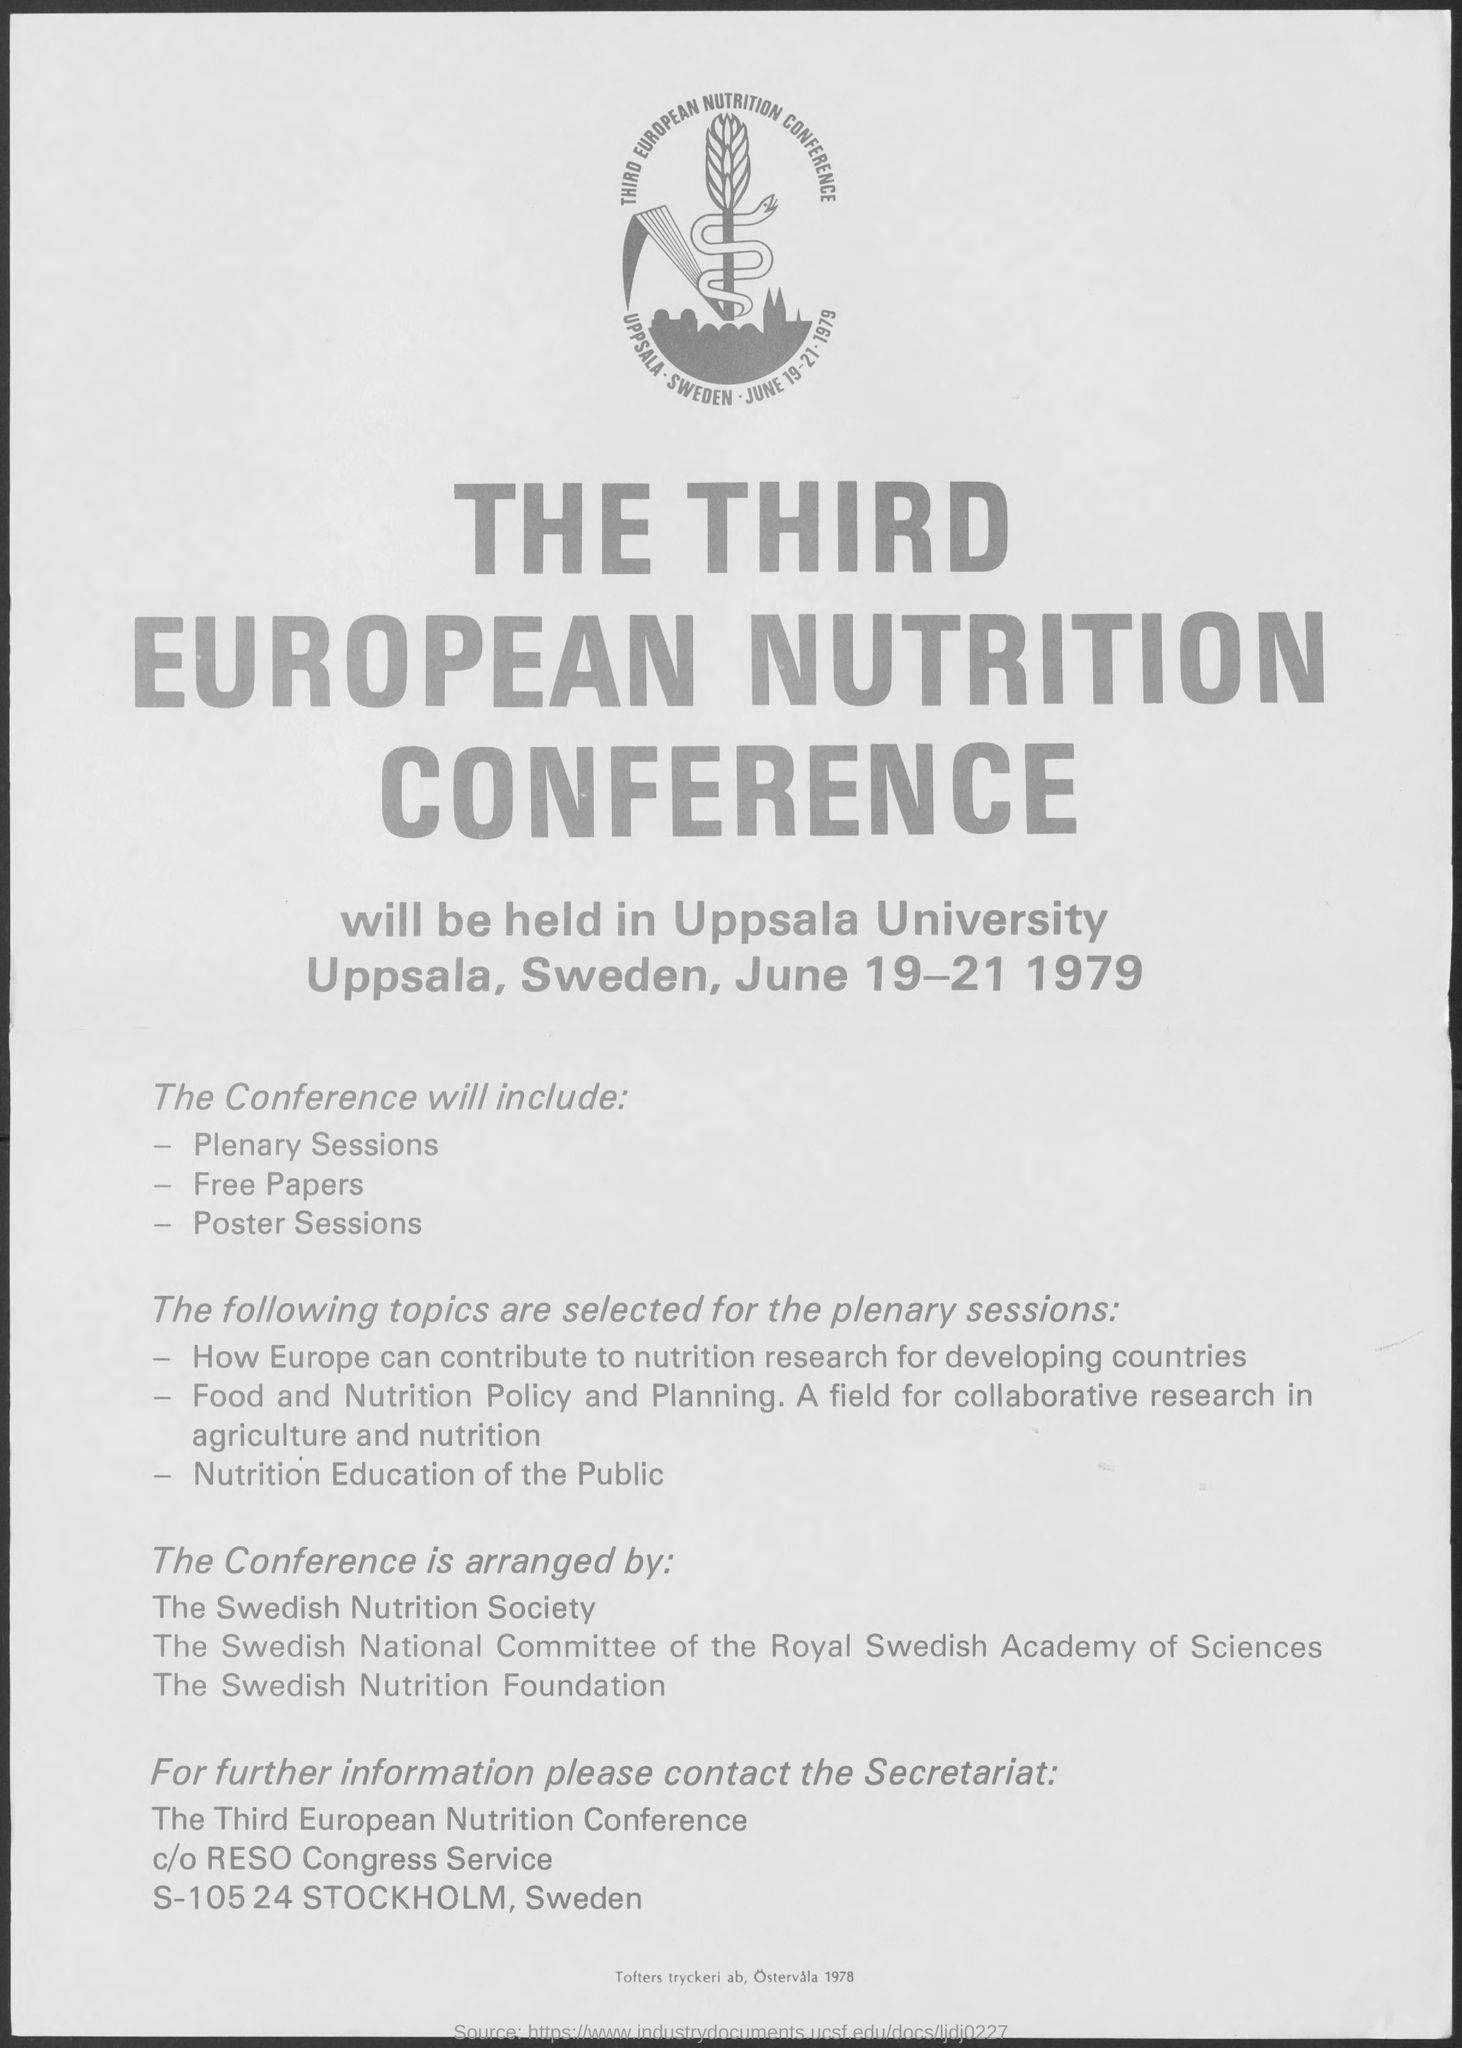When was ' THE THIRD EUROPEAN NUTRITION CONFERENCE' held?
Make the answer very short. JUNE 19-21 1979. 